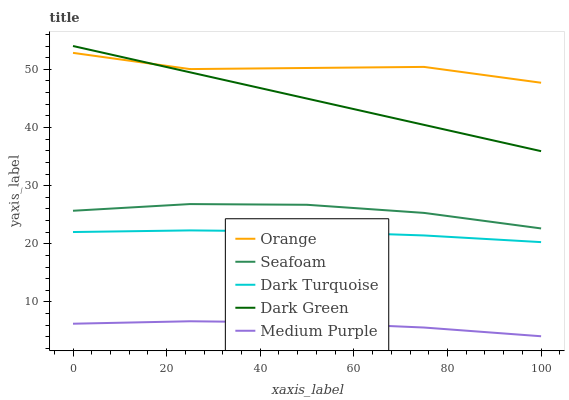Does Medium Purple have the minimum area under the curve?
Answer yes or no. Yes. Does Orange have the maximum area under the curve?
Answer yes or no. Yes. Does Dark Turquoise have the minimum area under the curve?
Answer yes or no. No. Does Dark Turquoise have the maximum area under the curve?
Answer yes or no. No. Is Dark Green the smoothest?
Answer yes or no. Yes. Is Orange the roughest?
Answer yes or no. Yes. Is Dark Turquoise the smoothest?
Answer yes or no. No. Is Dark Turquoise the roughest?
Answer yes or no. No. Does Medium Purple have the lowest value?
Answer yes or no. Yes. Does Dark Turquoise have the lowest value?
Answer yes or no. No. Does Dark Green have the highest value?
Answer yes or no. Yes. Does Dark Turquoise have the highest value?
Answer yes or no. No. Is Seafoam less than Dark Green?
Answer yes or no. Yes. Is Orange greater than Medium Purple?
Answer yes or no. Yes. Does Dark Green intersect Orange?
Answer yes or no. Yes. Is Dark Green less than Orange?
Answer yes or no. No. Is Dark Green greater than Orange?
Answer yes or no. No. Does Seafoam intersect Dark Green?
Answer yes or no. No. 